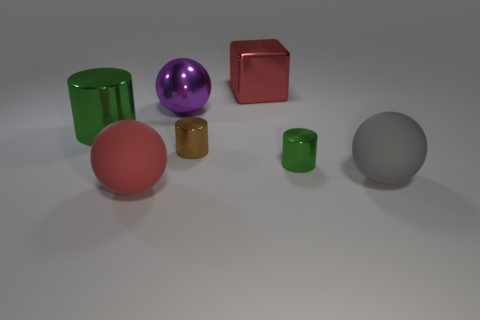Can you tell me which objects seem to have a reflective surface? Certainly! The purple sphere, the green cylinder, and the red cube exhibit reflective surfaces, as indicated by the highlights and the visible environment reflections on them. 